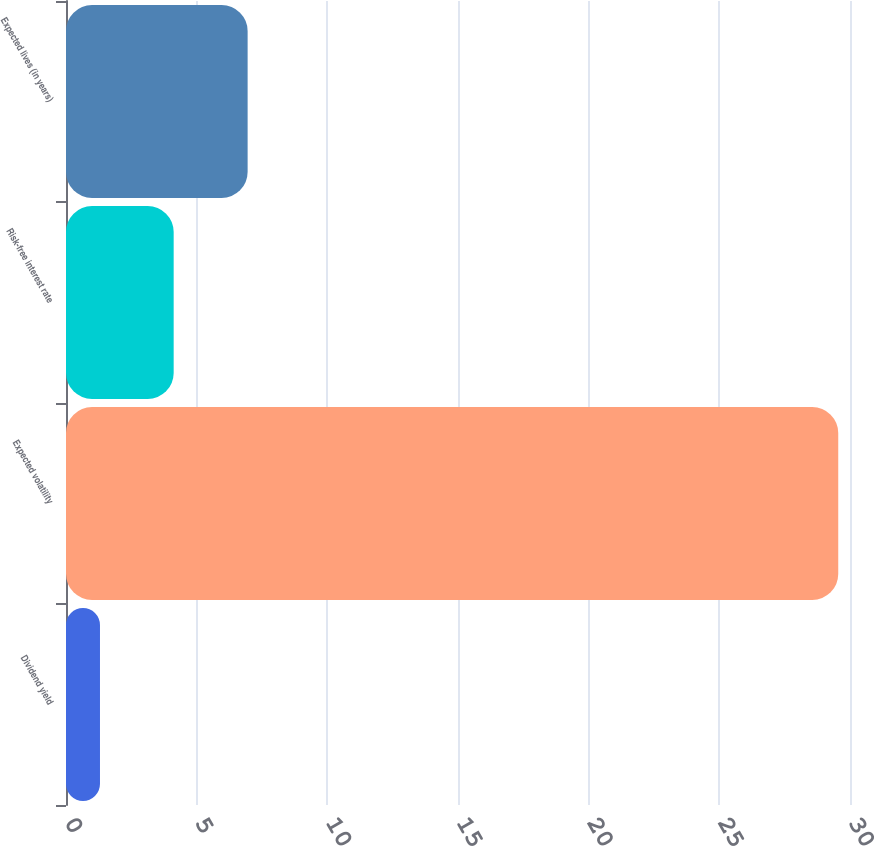Convert chart to OTSL. <chart><loc_0><loc_0><loc_500><loc_500><bar_chart><fcel>Dividend yield<fcel>Expected volatility<fcel>Risk-free interest rate<fcel>Expected lives (in years)<nl><fcel>1.3<fcel>29.55<fcel>4.12<fcel>6.95<nl></chart> 